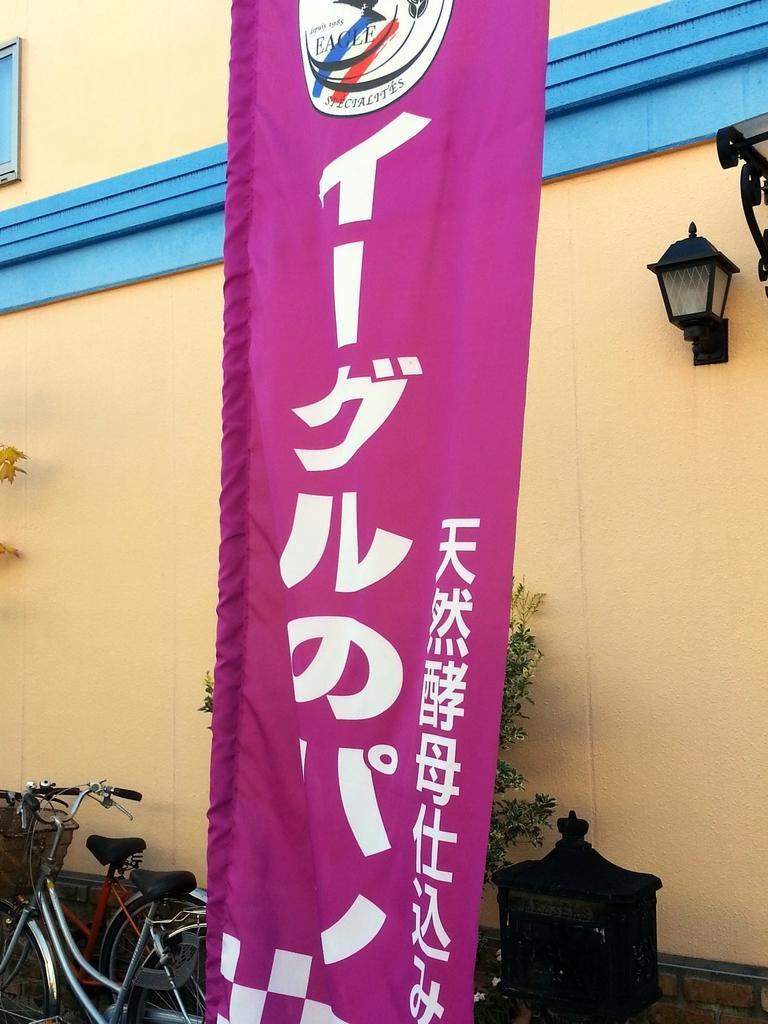How would you summarize this image in a sentence or two? This is a banner hanging. I can see two bicycles, which are parked. This looks like a wooden object. I think this is a tree, which is behind the banner. This looks like a lamp, which is attached to the building wall. 